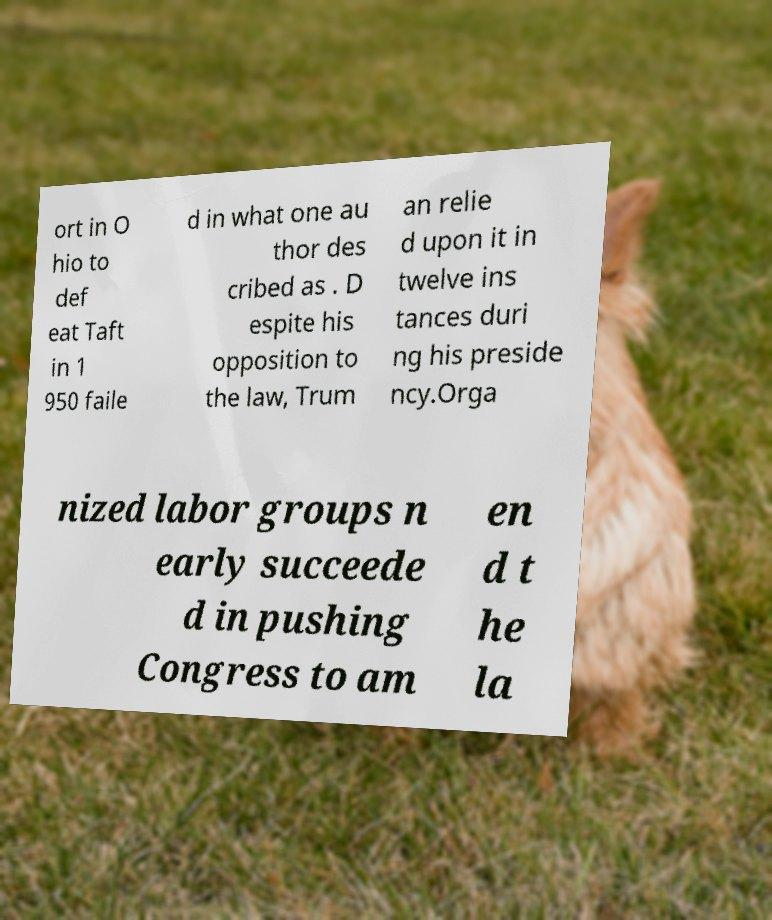Please identify and transcribe the text found in this image. ort in O hio to def eat Taft in 1 950 faile d in what one au thor des cribed as . D espite his opposition to the law, Trum an relie d upon it in twelve ins tances duri ng his preside ncy.Orga nized labor groups n early succeede d in pushing Congress to am en d t he la 